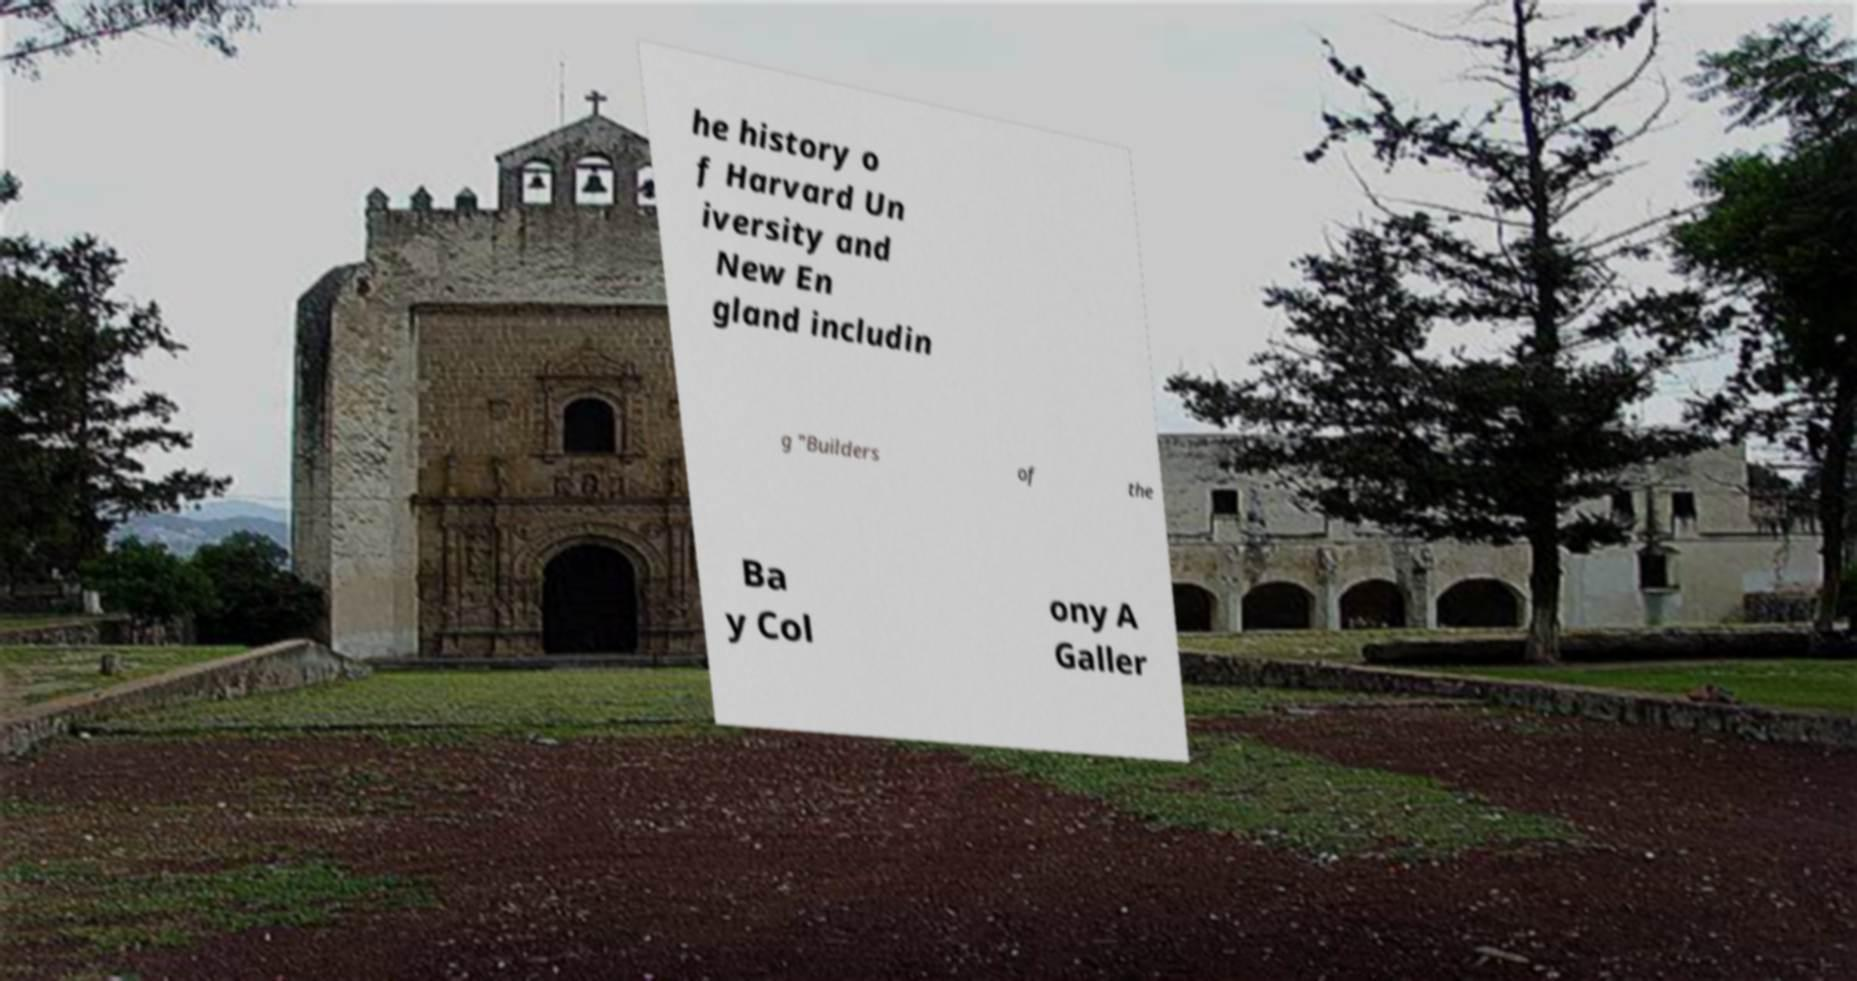What messages or text are displayed in this image? I need them in a readable, typed format. he history o f Harvard Un iversity and New En gland includin g "Builders of the Ba y Col ony A Galler 